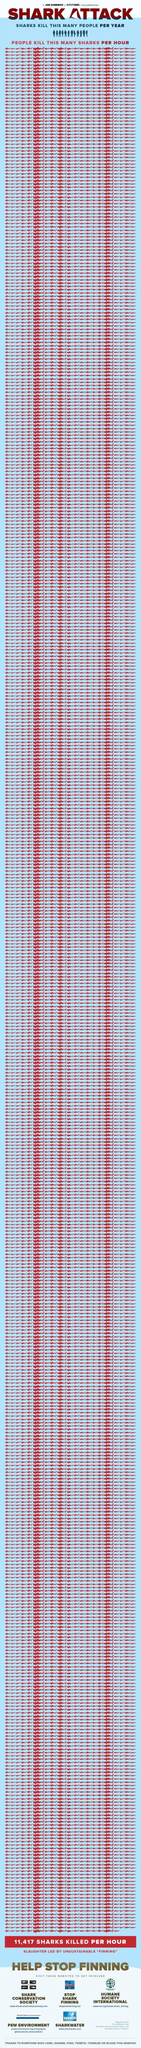How many people are killed by Shark every year?
Answer the question with a short phrase. 12 